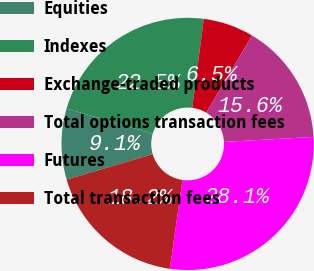<chart> <loc_0><loc_0><loc_500><loc_500><pie_chart><fcel>Equities<fcel>Indexes<fcel>Exchange-traded products<fcel>Total options transaction fees<fcel>Futures<fcel>Total transaction fees<nl><fcel>9.09%<fcel>22.51%<fcel>6.49%<fcel>15.58%<fcel>28.14%<fcel>18.18%<nl></chart> 